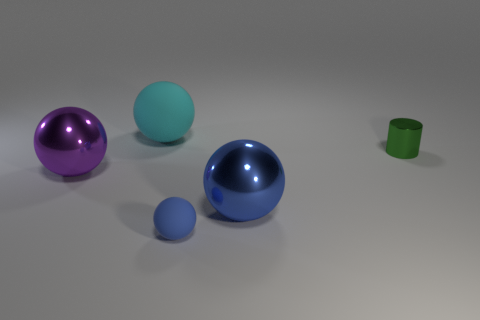Subtract all cyan matte spheres. How many spheres are left? 3 Subtract all purple spheres. How many spheres are left? 3 Subtract all red spheres. Subtract all brown cylinders. How many spheres are left? 4 Add 3 small purple rubber cubes. How many objects exist? 8 Subtract all spheres. How many objects are left? 1 Add 5 shiny things. How many shiny things are left? 8 Add 5 yellow things. How many yellow things exist? 5 Subtract 0 brown balls. How many objects are left? 5 Subtract all green metallic objects. Subtract all large blue spheres. How many objects are left? 3 